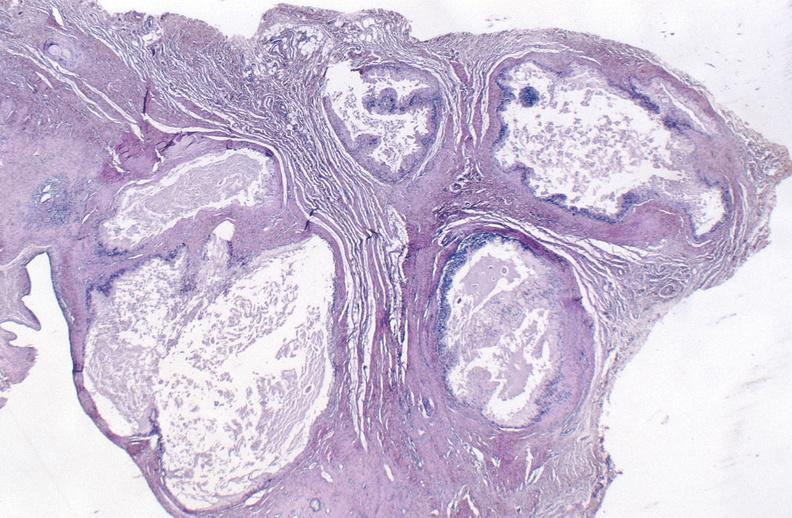what does this image show?
Answer the question using a single word or phrase. Gout 